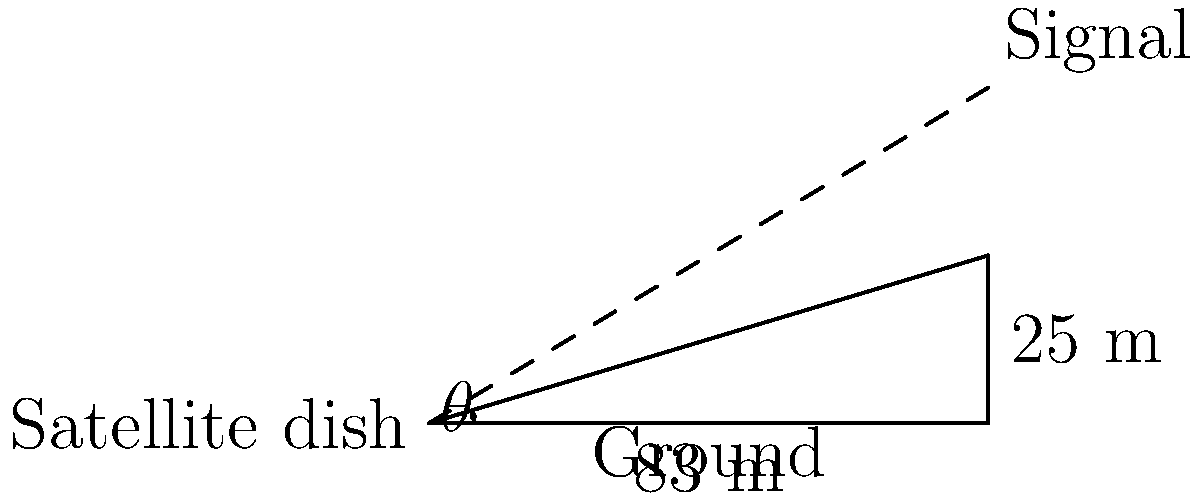As a codebreaker intercepting Soviet communications, you need to position a satellite dish to receive signals from a distant source. The signal is coming from a point 83 meters away horizontally and 25 meters above the ground. What is the angle of elevation $\theta$ (in degrees, rounded to the nearest whole number) at which you should position the satellite dish to intercept the signal? To solve this problem, we'll use trigonometry:

1) We have a right triangle where:
   - The adjacent side (ground distance) is 83 meters
   - The opposite side (height) is 25 meters
   - We need to find the angle $\theta$

2) The tangent of an angle in a right triangle is the ratio of the opposite side to the adjacent side:

   $$\tan(\theta) = \frac{\text{opposite}}{\text{adjacent}} = \frac{25}{83}$$

3) To find $\theta$, we need to use the inverse tangent (arctangent) function:

   $$\theta = \arctan(\frac{25}{83})$$

4) Using a calculator or computer:

   $$\theta \approx 16.77^\circ$$

5) Rounding to the nearest whole number:

   $$\theta \approx 17^\circ$$

Therefore, the satellite dish should be positioned at an angle of elevation of 17 degrees to intercept the signal.
Answer: $17^\circ$ 